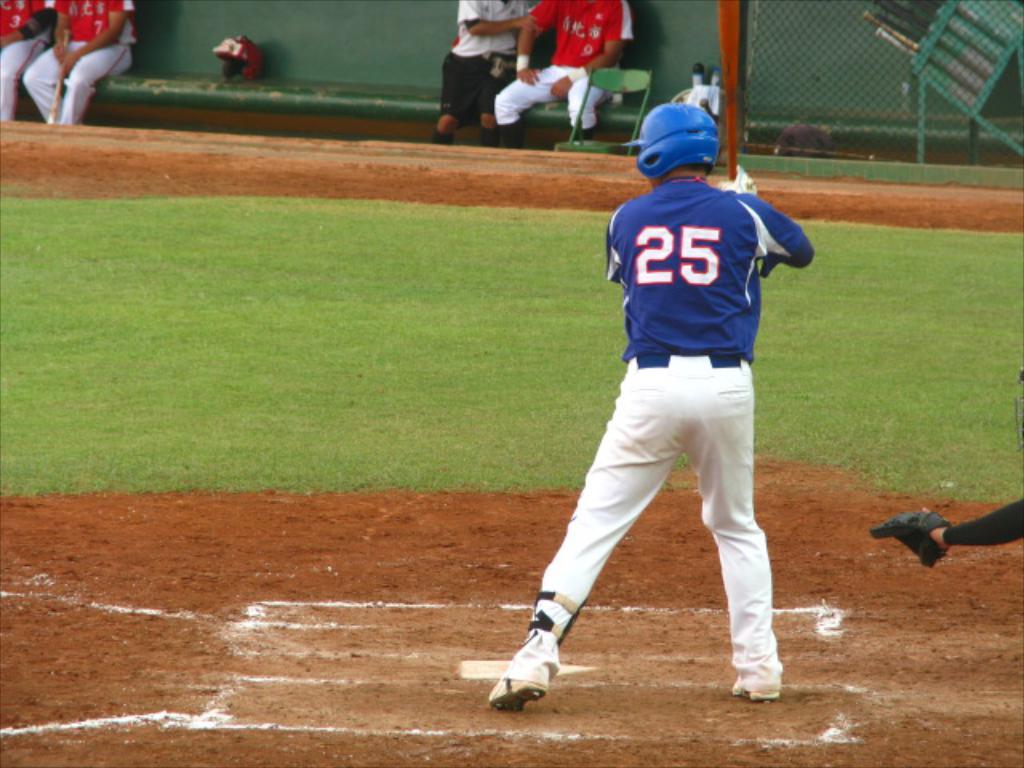What number is the player in blue?
Your answer should be compact. 25. 25 blue player?
Your answer should be compact. Yes. 